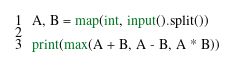<code> <loc_0><loc_0><loc_500><loc_500><_Python_>A, B = map(int, input().split())

print(max(A + B, A - B, A * B))</code> 